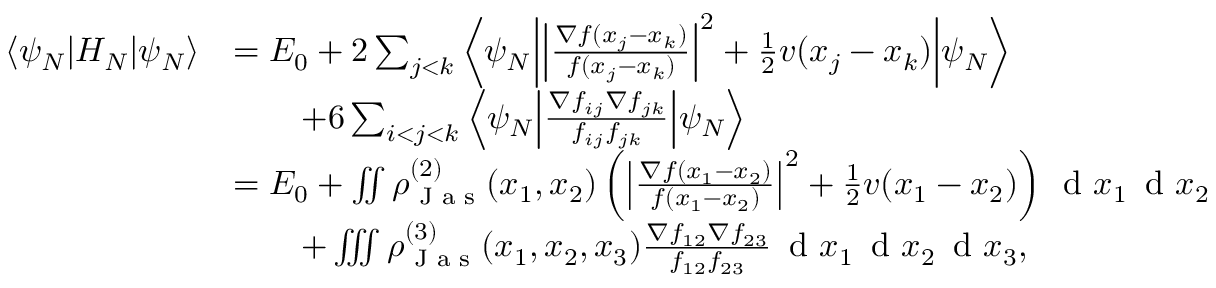Convert formula to latex. <formula><loc_0><loc_0><loc_500><loc_500>\begin{array} { r l } { \left \langle \psi _ { N } | d l e | H _ { N } | d l e | \psi _ { N } \right \rangle } & { = E _ { 0 } + 2 \sum _ { j < k } \left \langle \psi _ { N } | d l e | \left | \frac { \nabla f ( x _ { j } - x _ { k } ) } { f ( x _ { j } - x _ { k } ) } \right | ^ { 2 } + \frac { 1 } { 2 } v ( x _ { j } - x _ { k } ) | d l e | \psi _ { N } \right \rangle } \\ & { \quad + 6 \sum _ { i < j < k } \left \langle \psi _ { N } | d l e | \frac { \nabla f _ { i j } \nabla f _ { j k } } { f _ { i j } f _ { j k } } | d l e | \psi _ { N } \right \rangle } \\ & { = E _ { 0 } + \iint \rho _ { J a s } ^ { ( 2 ) } ( x _ { 1 } , x _ { 2 } ) \left ( \left | \frac { \nabla f ( x _ { 1 } - x _ { 2 } ) } { f ( x _ { 1 } - x _ { 2 } ) } \right | ^ { 2 } + \frac { 1 } { 2 } v ( x _ { 1 } - x _ { 2 } ) \right ) \, d x _ { 1 } \, d x _ { 2 } } \\ & { \quad + \iiint \rho _ { J a s } ^ { ( 3 ) } ( x _ { 1 } , x _ { 2 } , x _ { 3 } ) \frac { \nabla f _ { 1 2 } \nabla f _ { 2 3 } } { f _ { 1 2 } f _ { 2 3 } } \, d x _ { 1 } \, d x _ { 2 } \, d x _ { 3 } , } \end{array}</formula> 